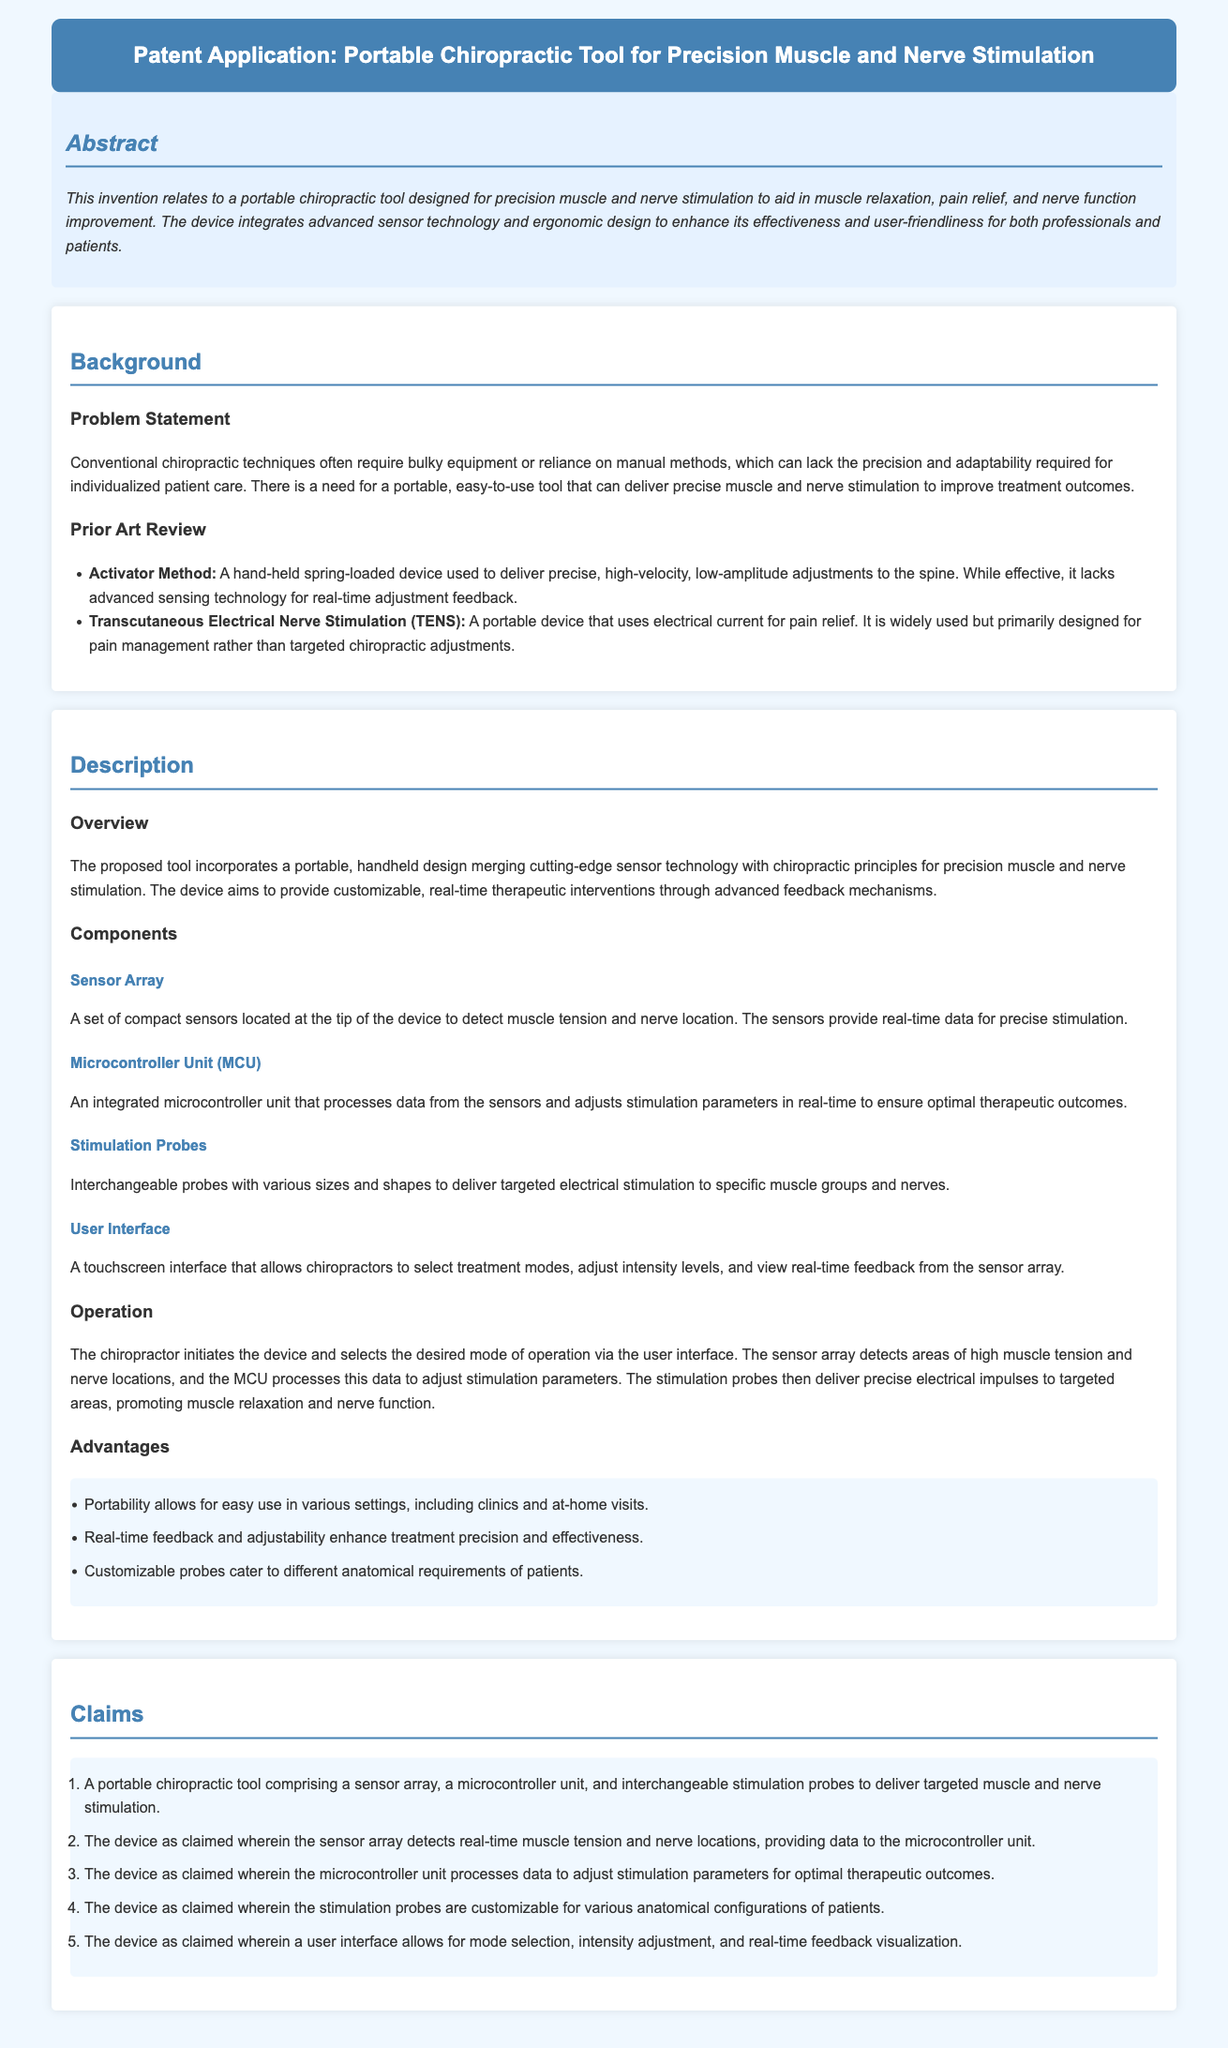What is the main purpose of the invention? The invention relates to a portable chiropractic tool designed for precision muscle and nerve stimulation to aid in muscle relaxation, pain relief, and nerve function improvement.
Answer: muscle relaxation, pain relief, and nerve function improvement What technology does the tool integrate? The document states that the device integrates advanced sensor technology and ergonomic design.
Answer: advanced sensor technology and ergonomic design What is the role of the Microcontroller Unit (MCU)? The MCU processes data from the sensors and adjusts stimulation parameters in real-time to ensure optimal therapeutic outcomes.
Answer: processes data and adjusts stimulation parameters What advantage does the portability of the device provide? The portability allows for easy use in various settings, including clinics and at-home visits.
Answer: easy use in various settings What components are included in the device? The device comprises a sensor array, a microcontroller unit, and interchangeable stimulation probes.
Answer: sensor array, microcontroller unit, and interchangeable stimulation probes How does the user interact with the device? The user interface allows chiropractors to select treatment modes, adjust intensity levels, and view real-time feedback from the sensor array.
Answer: touchscreen interface What does the sensor array detect? The sensor array detects muscle tension and nerve location.
Answer: muscle tension and nerve location What is the significance of real-time feedback? Real-time feedback and adjustability enhance treatment precision and effectiveness.
Answer: enhance treatment precision and effectiveness How many claims are made in this patent application? The document lists a total of five claims regarding the device.
Answer: five claims 